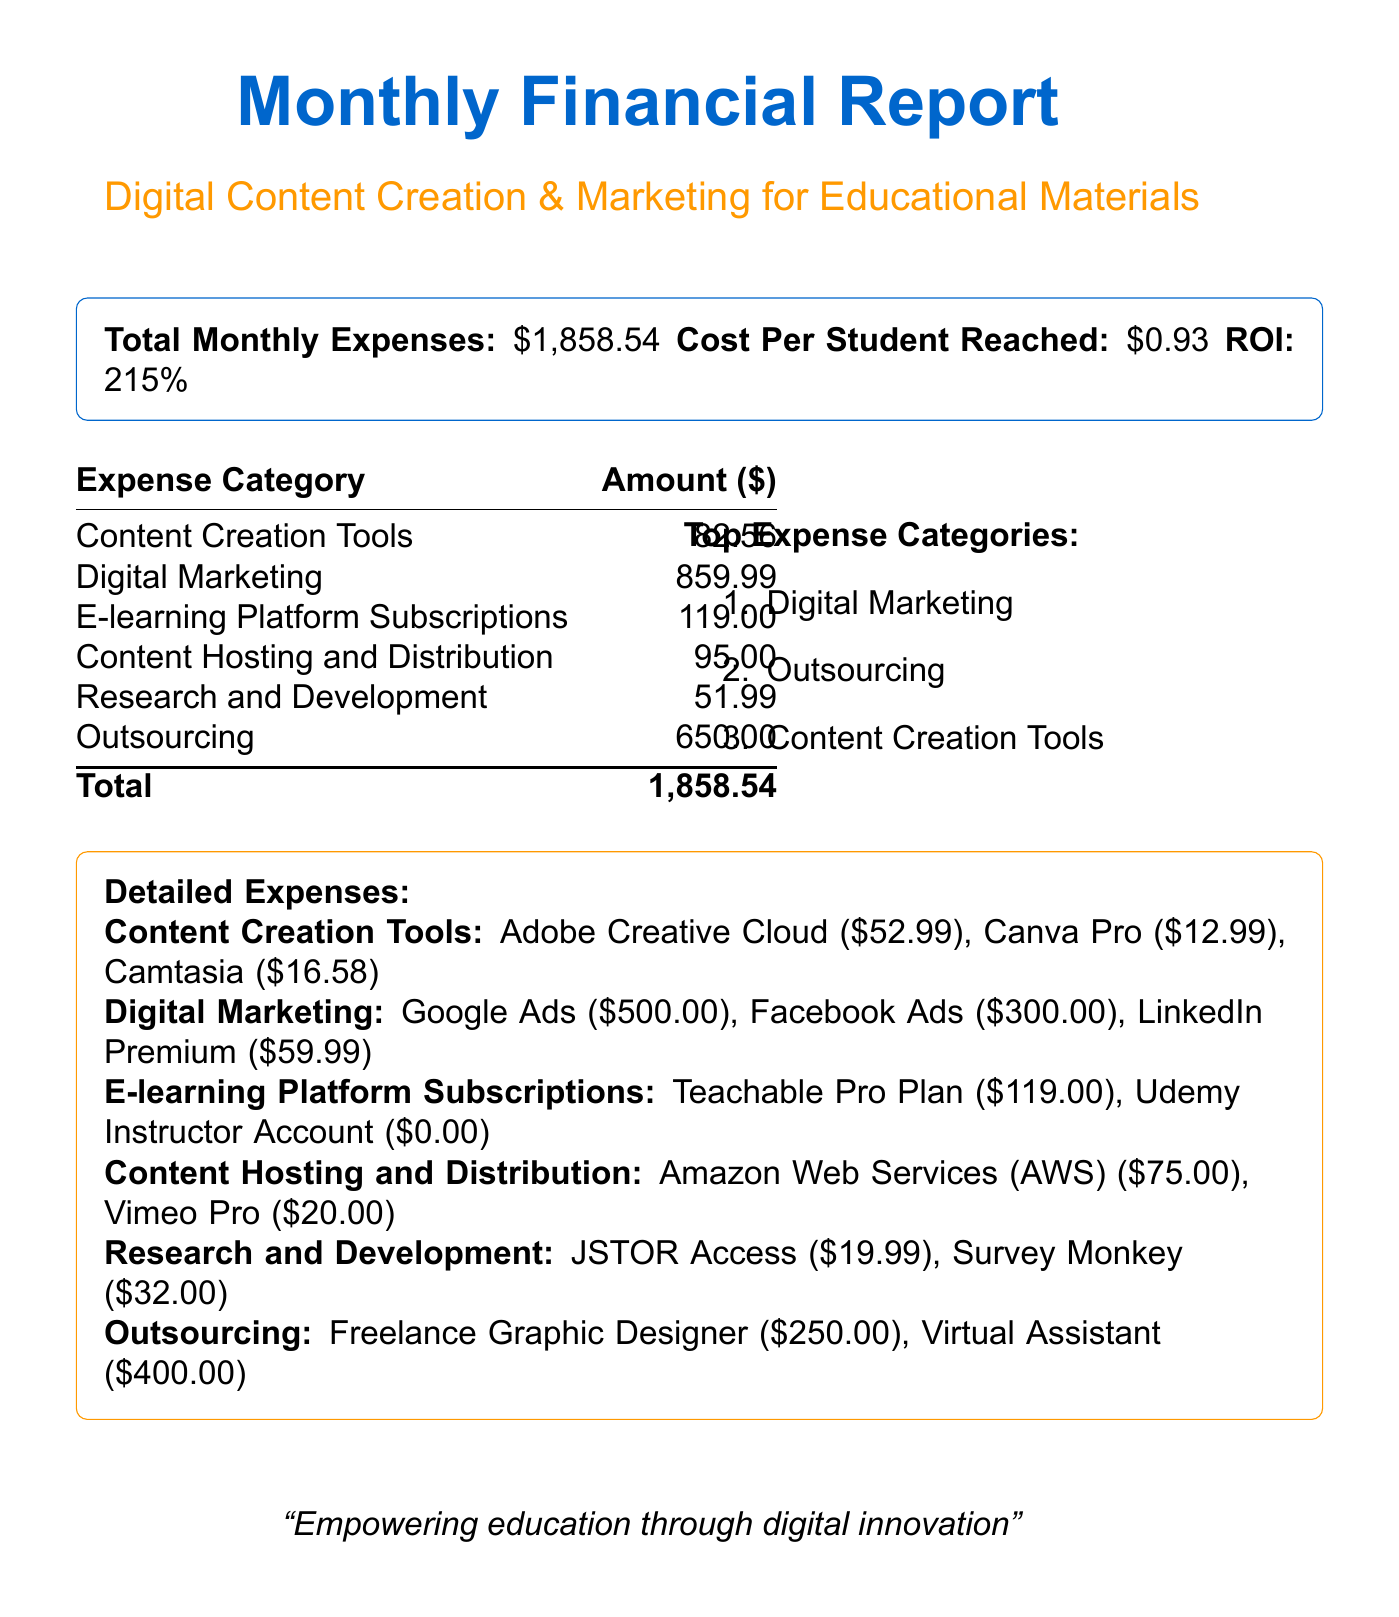What is the total monthly expense? The total monthly expense is clearly stated at the beginning of the document, which sums up all expense categories.
Answer: $1,858.54 Which category has the highest expense? The highest expense category can be identified from the 'Top Expense Categories' section of the document.
Answer: Digital Marketing How much is spent on Digital Marketing? The expense breakdown table lists the amount allocated to Digital Marketing.
Answer: $859.99 What is the cost per student reached? This value is provided in the summary at the beginning of the document, indicating marketing efficiency.
Answer: $0.93 How much is spent on Outsourcing? The Outsourcing expenses are totaled in the expense breakdown table.
Answer: $650.00 Which tool costs the least in the Content Creation Tools category? The itemized list in the document shows the costs of each tool; identifying the lowest gives the answer.
Answer: Canva Pro What is the total cost for Content Hosting and Distribution? The sum of items listed under Content Hosting and Distribution in the expenses section provides this total.
Answer: $95.00 What is the return on investment? The ROI value is presented in the summary section of the document, reflecting the financial health of the marketing efforts.
Answer: 215% What is the cost for the Teachable Pro Plan? This information is found in the E-learning Platform Subscriptions expense category listing.
Answer: $119.00 What are the two items listed under Research and Development? The document specifies the expenses for Research and Development, detailing each item explicitly.
Answer: JSTOR Access, Survey Monkey 